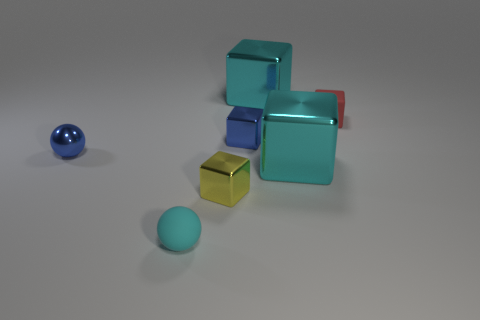The metal thing that is the same color as the tiny metal sphere is what size?
Offer a very short reply. Small. Are there any large red spheres that have the same material as the cyan ball?
Keep it short and to the point. No. The tiny rubber cube is what color?
Make the answer very short. Red. There is a blue metal object right of the small metal cube that is in front of the tiny metal thing that is left of the small yellow object; what is its size?
Your answer should be compact. Small. How many other things are there of the same shape as the tiny cyan object?
Give a very brief answer. 1. There is a tiny thing that is both to the right of the yellow object and on the left side of the tiny rubber block; what color is it?
Make the answer very short. Blue. Is there anything else that is the same size as the red rubber cube?
Offer a very short reply. Yes. Does the small matte thing that is to the right of the cyan rubber object have the same color as the metallic sphere?
Offer a terse response. No. How many spheres are either large cyan shiny things or red matte objects?
Your answer should be very brief. 0. What shape is the tiny object in front of the yellow shiny object?
Keep it short and to the point. Sphere. 